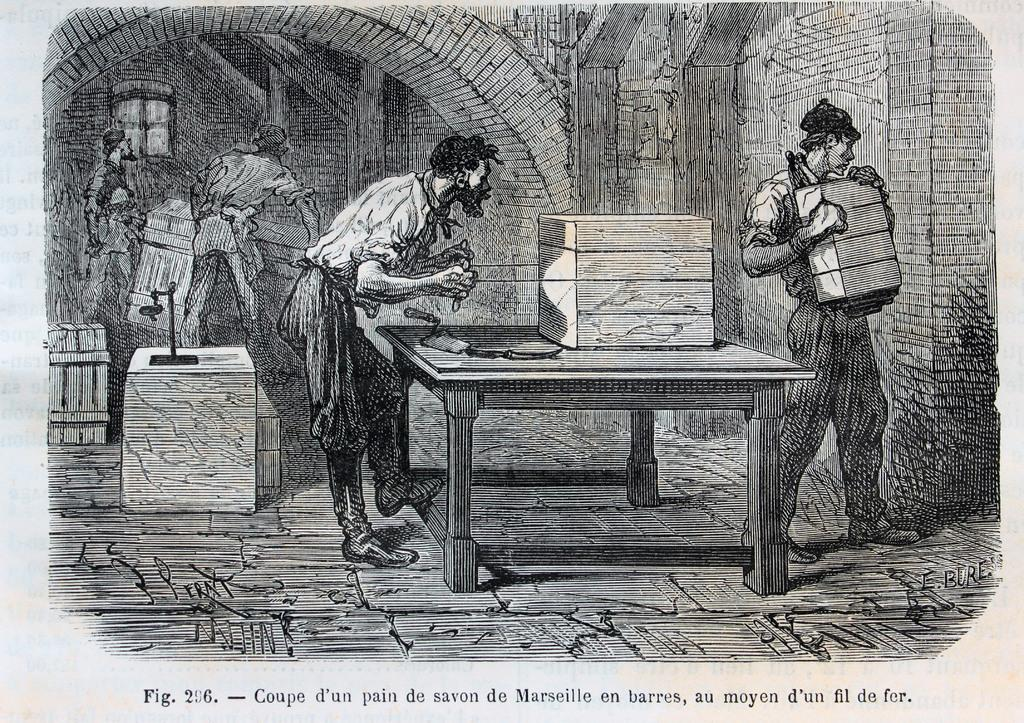What is the main subject of the image? The image contains a sketch. How many people are depicted in the sketch? There are two men in the sketch. What are the men doing in the sketch? One man is holding bricks, and the other man is working on a table. What type of construction is visible in the sketch? The men are standing under an old construction. What type of wool is being used by the man working on the table in the image? There is no wool present in the image; the man is working on a table, but no wool is mentioned or visible. 